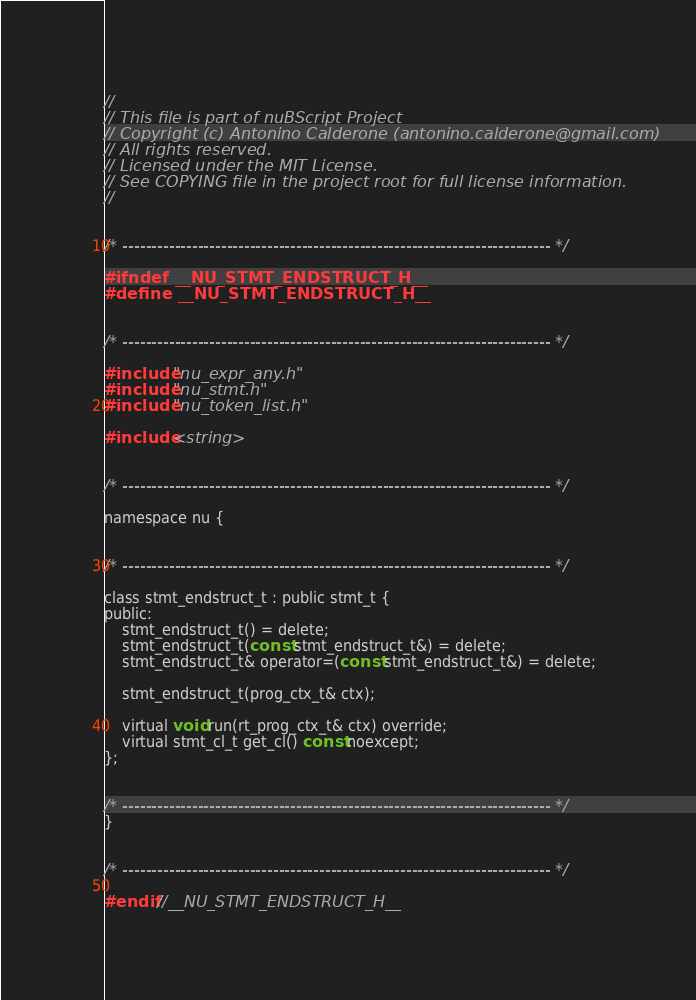Convert code to text. <code><loc_0><loc_0><loc_500><loc_500><_C_>//  
// This file is part of nuBScript Project
// Copyright (c) Antonino Calderone (antonino.calderone@gmail.com)
// All rights reserved.  
// Licensed under the MIT License. 
// See COPYING file in the project root for full license information.
//


/* -------------------------------------------------------------------------- */

#ifndef __NU_STMT_ENDSTRUCT_H__
#define __NU_STMT_ENDSTRUCT_H__


/* -------------------------------------------------------------------------- */

#include "nu_expr_any.h"
#include "nu_stmt.h"
#include "nu_token_list.h"

#include <string>


/* -------------------------------------------------------------------------- */

namespace nu {


/* -------------------------------------------------------------------------- */

class stmt_endstruct_t : public stmt_t {
public:
    stmt_endstruct_t() = delete;
    stmt_endstruct_t(const stmt_endstruct_t&) = delete;
    stmt_endstruct_t& operator=(const stmt_endstruct_t&) = delete;

    stmt_endstruct_t(prog_ctx_t& ctx);

    virtual void run(rt_prog_ctx_t& ctx) override;
    virtual stmt_cl_t get_cl() const noexcept;
};


/* -------------------------------------------------------------------------- */
}


/* -------------------------------------------------------------------------- */

#endif //__NU_STMT_ENDSTRUCT_H__</code> 